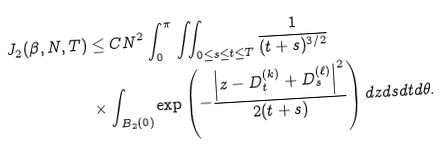<formula> <loc_0><loc_0><loc_500><loc_500>J _ { 2 } ( \beta , N , T ) & \leq C N ^ { 2 } \int _ { 0 } ^ { \pi } \iint _ { 0 \leq s \leq t \leq T } \frac { 1 } { ( t + s ) ^ { 3 / 2 } } \\ & \times \int _ { B _ { 2 } ( 0 ) } \exp \left ( - \frac { \left | z - D _ { t } ^ { ( k ) } + D _ { s } ^ { ( \ell ) } \right | ^ { 2 } } { 2 ( t + s ) } \right ) d z d s d t d \theta .</formula> 